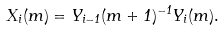Convert formula to latex. <formula><loc_0><loc_0><loc_500><loc_500>X _ { i } ( m ) = Y _ { i - 1 } ( m + 1 ) ^ { - 1 } Y _ { i } ( m ) .</formula> 